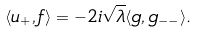<formula> <loc_0><loc_0><loc_500><loc_500>\langle u _ { + } , f \rangle = - 2 i \sqrt { \lambda } \langle g , g _ { - - } \rangle .</formula> 